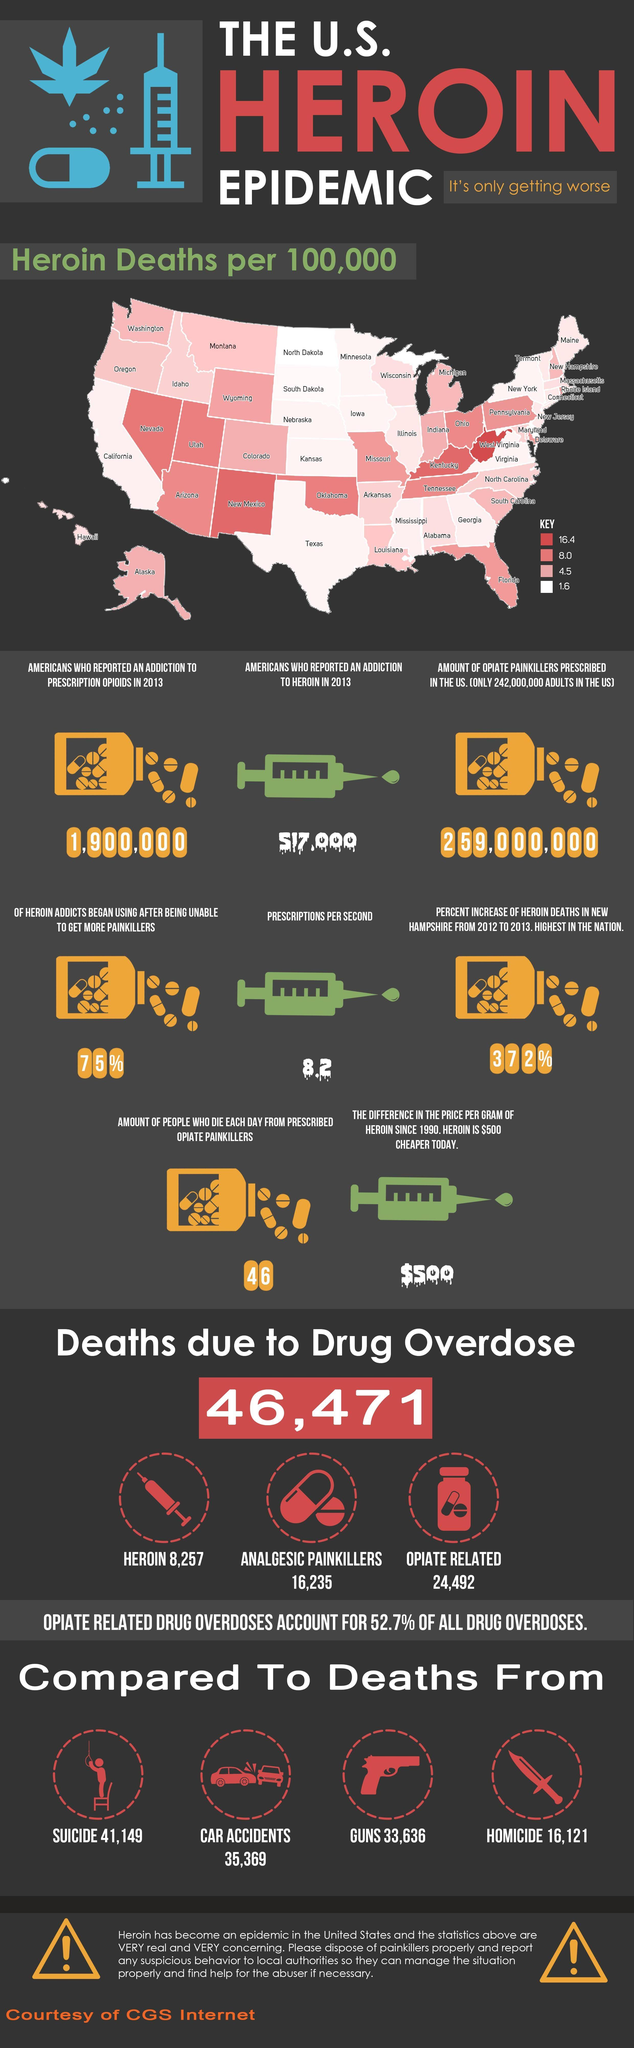Specify some key components in this picture. In 2013, it was reported that approximately 517,000 Americans suffered from an addiction to heroin. The number of deaths by suicide is greater than that by heroin overdose by 32,892. According to the data, approximately 52.7% of drug overdose deaths that were caused by digging are related to opiates. In 2013, it was reported that 1,900,000 Americans self-identified as having an addiction to prescription opioids. In Colorado, there were approximately 4.5 deaths per 100,000 people in a given year. 